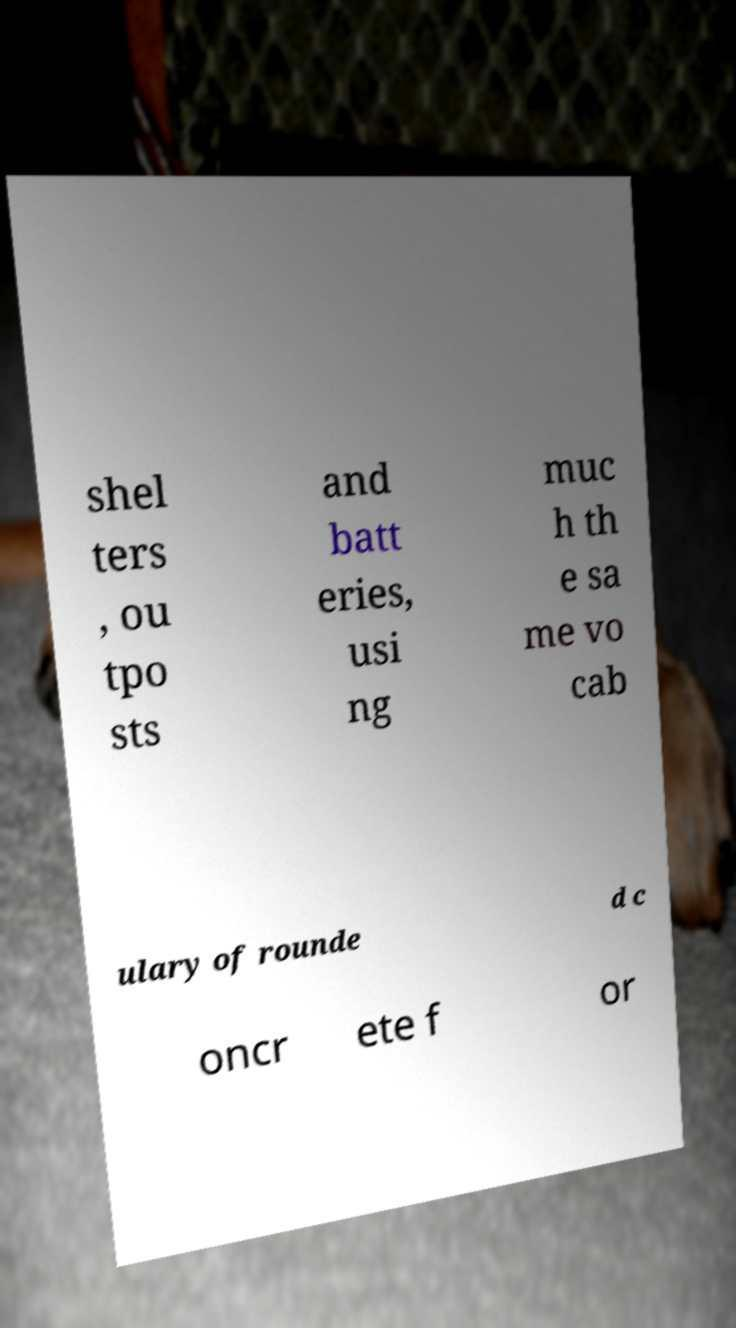For documentation purposes, I need the text within this image transcribed. Could you provide that? shel ters , ou tpo sts and batt eries, usi ng muc h th e sa me vo cab ulary of rounde d c oncr ete f or 